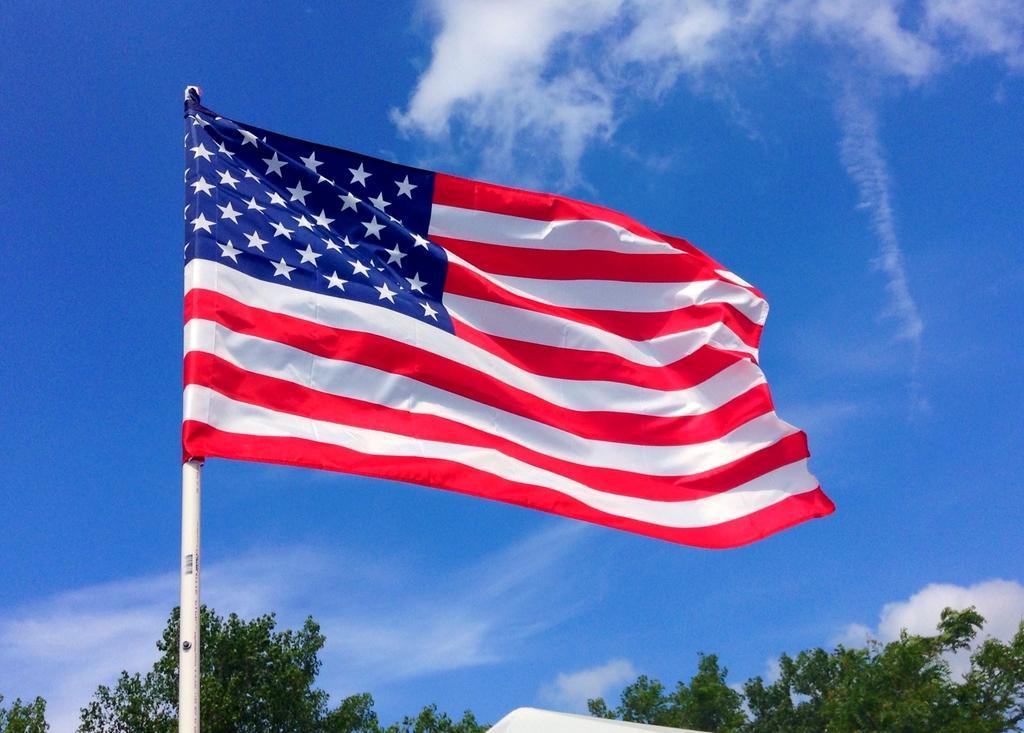Can you describe this image briefly? In this image we can see a flag and a pole. At the bottom of the image we can see branches and leaves. In the background there is sky with clouds. 